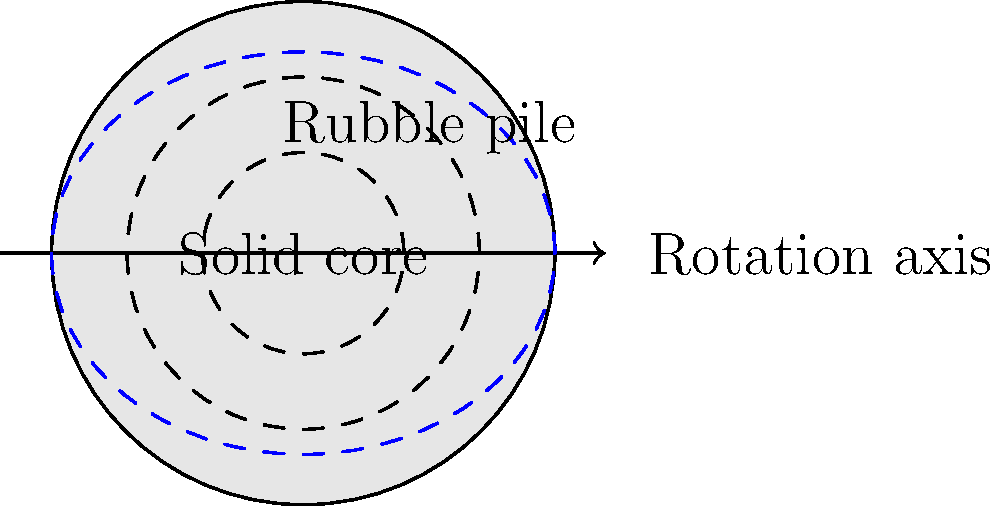Based on the cross-sectional diagram of an asteroid, which shows a slightly oblate shape (blue dashed line) compared to a perfect circle, and given that its rotation period is 2.5 hours, what can be inferred about its internal structure? Assume the asteroid has a diameter of approximately 1 km. To determine the internal structure of the asteroid, we need to consider several factors:

1. Shape: The asteroid is slightly oblate, indicating it has been deformed by rotational forces.

2. Rotation period: The given period is 2.5 hours, which is relatively fast for an asteroid of this size.

3. Critical rotation period: We need to calculate the critical rotation period for a strengthless body (rubble pile) of this size.

The critical rotation period $T_c$ for a strengthless body is given by:

$$T_c = \sqrt{\frac{3\pi}{G\rho}}$$

where $G$ is the gravitational constant and $\rho$ is the bulk density of the asteroid.

Assuming a typical asteroid density of $\rho = 2000 \text{ kg/m}^3$:

$$T_c = \sqrt{\frac{3\pi}{(6.67 \times 10^{-11})(2000)}} \approx 2.3 \text{ hours}$$

4. Comparison: The asteroid's rotation period (2.5 hours) is slightly longer than the critical period (2.3 hours) for a rubble pile.

5. Internal structure inference:
   a) The asteroid is rotating fast, but not fast enough to completely break apart.
   b) Its oblate shape suggests some internal deformation has occurred.
   c) The rotation period is close to, but above, the critical period for a rubble pile.

These factors indicate that the asteroid likely has a rubble pile structure with a possible solid core, as shown in the diagram. The rubble pile allows for some deformation, explaining the oblate shape, while the solid core provides some additional structural integrity, allowing it to rotate slightly faster than a pure rubble pile without breaking apart.
Answer: Rubble pile with possible solid core 